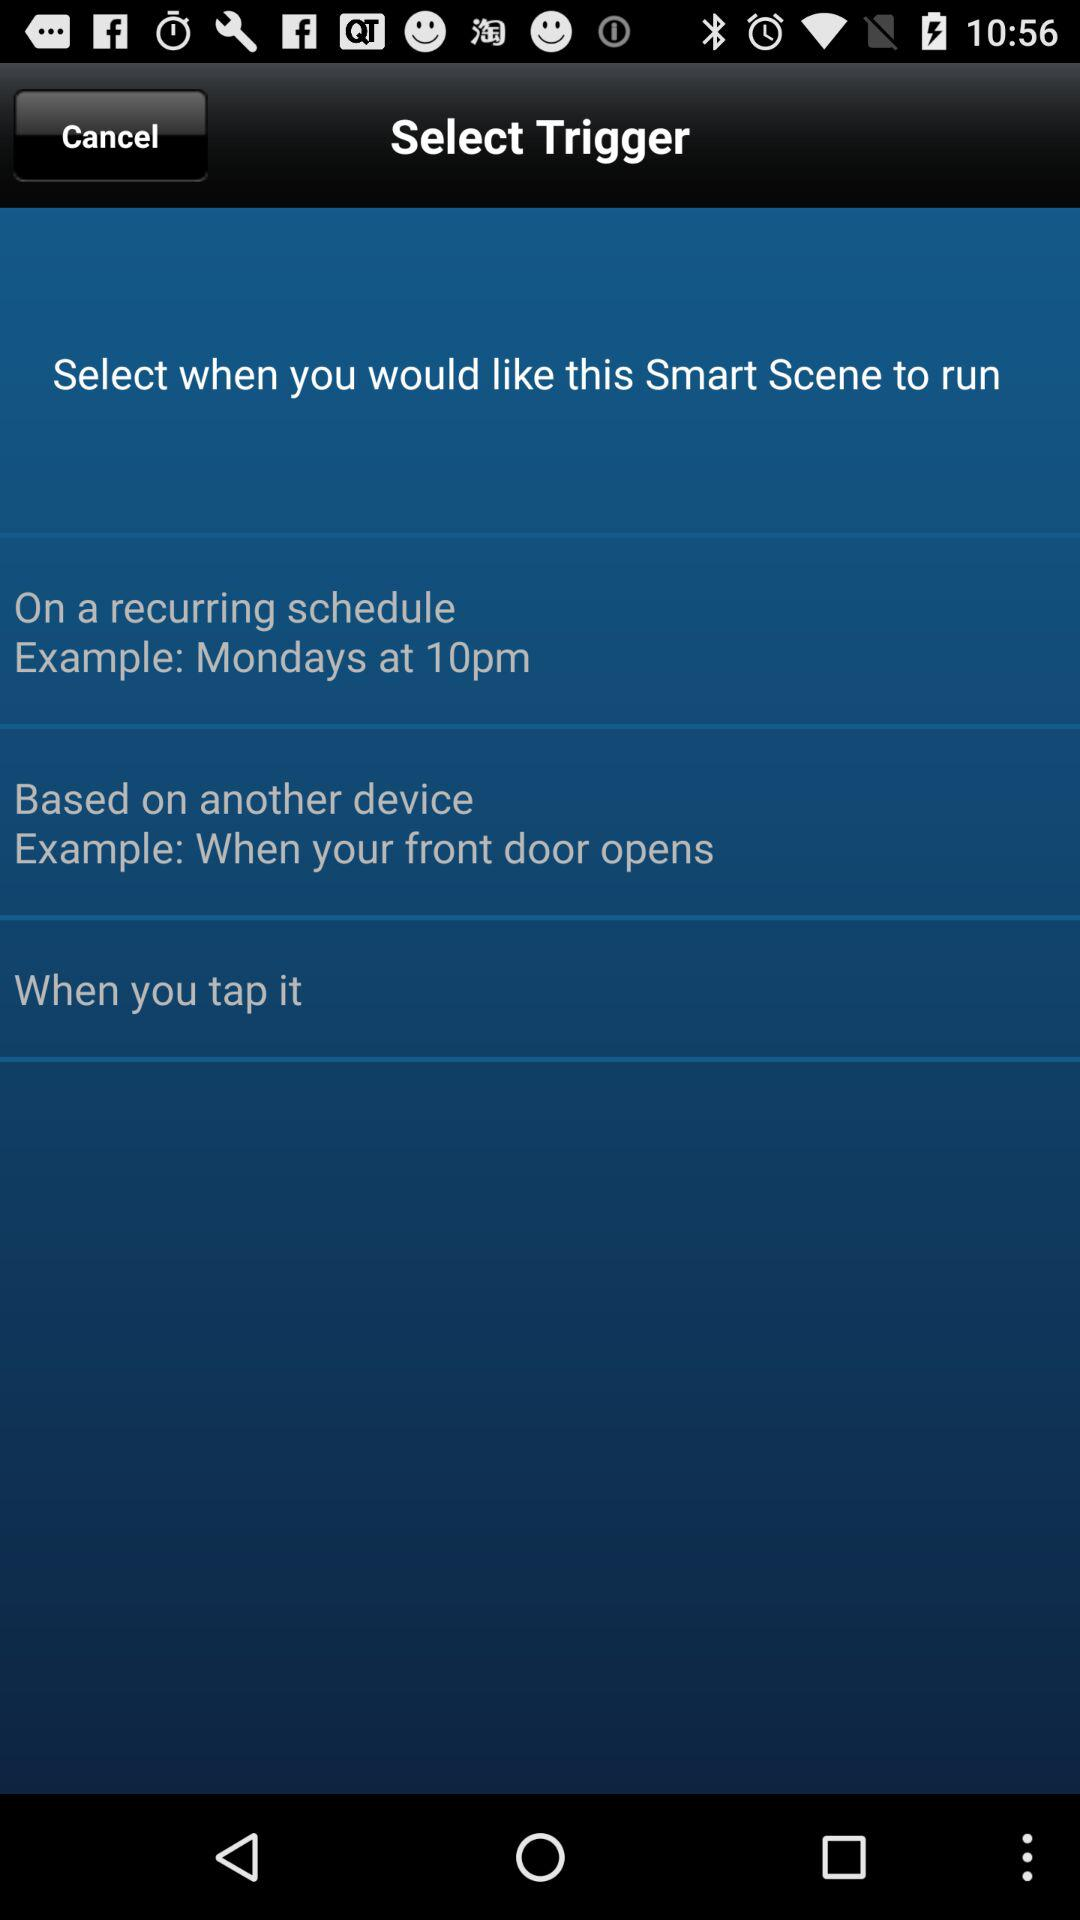How many trigger options are available?
Answer the question using a single word or phrase. 3 